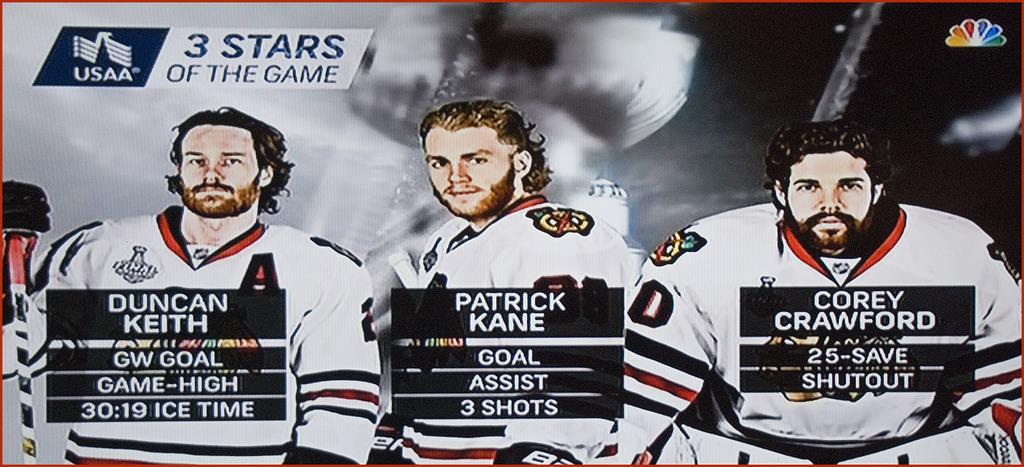Does it say 3 stars of the game in the top left?
Your answer should be very brief. Yes. Who are the players?
Give a very brief answer. Duncan keith, patrick kane, corey crawford. 